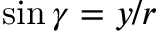Convert formula to latex. <formula><loc_0><loc_0><loc_500><loc_500>\sin { \gamma } = { y } / { r }</formula> 